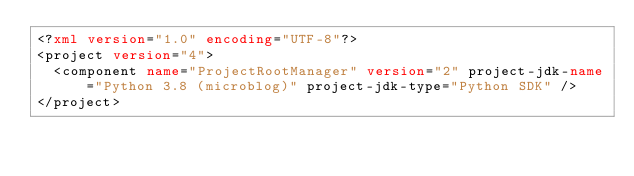Convert code to text. <code><loc_0><loc_0><loc_500><loc_500><_XML_><?xml version="1.0" encoding="UTF-8"?>
<project version="4">
  <component name="ProjectRootManager" version="2" project-jdk-name="Python 3.8 (microblog)" project-jdk-type="Python SDK" />
</project></code> 